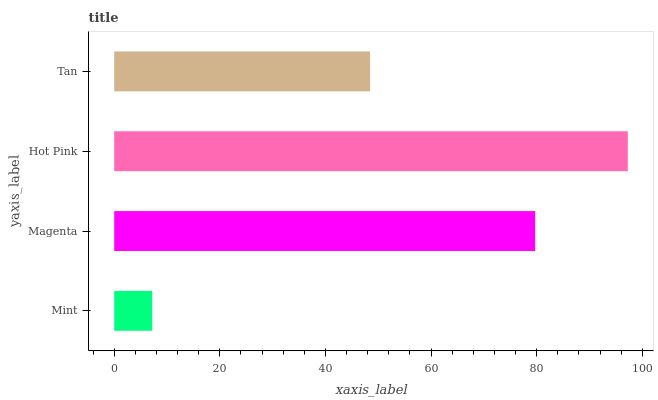Is Mint the minimum?
Answer yes or no. Yes. Is Hot Pink the maximum?
Answer yes or no. Yes. Is Magenta the minimum?
Answer yes or no. No. Is Magenta the maximum?
Answer yes or no. No. Is Magenta greater than Mint?
Answer yes or no. Yes. Is Mint less than Magenta?
Answer yes or no. Yes. Is Mint greater than Magenta?
Answer yes or no. No. Is Magenta less than Mint?
Answer yes or no. No. Is Magenta the high median?
Answer yes or no. Yes. Is Tan the low median?
Answer yes or no. Yes. Is Mint the high median?
Answer yes or no. No. Is Hot Pink the low median?
Answer yes or no. No. 